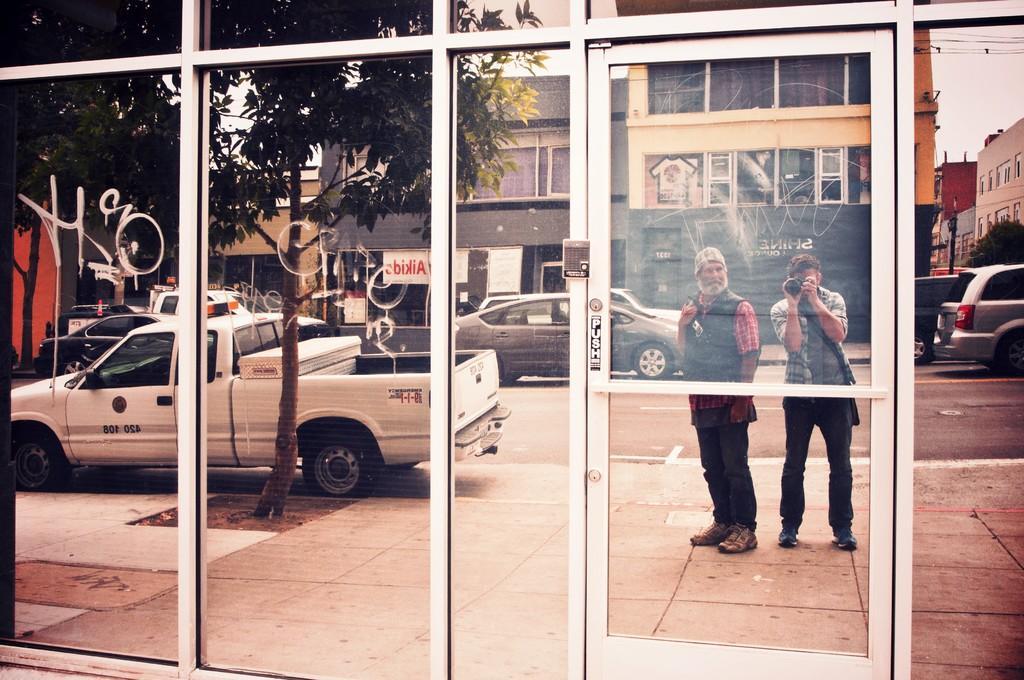Could you give a brief overview of what you see in this image? In the foreground of the picture I can see the glass door and glass windows. I can see the reflection of the buildings in the glass window. I can see the reflection of cars on the road. There is a reflection of trees on the top left side of the picture. I can see the reflection of the man holding the camera and there is another man beside him. 